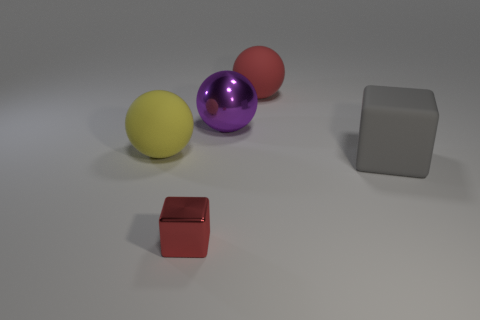Add 4 big gray cubes. How many objects exist? 9 Subtract all balls. How many objects are left? 2 Subtract 0 cyan spheres. How many objects are left? 5 Subtract all big red balls. Subtract all yellow objects. How many objects are left? 3 Add 5 gray cubes. How many gray cubes are left? 6 Add 1 blue balls. How many blue balls exist? 1 